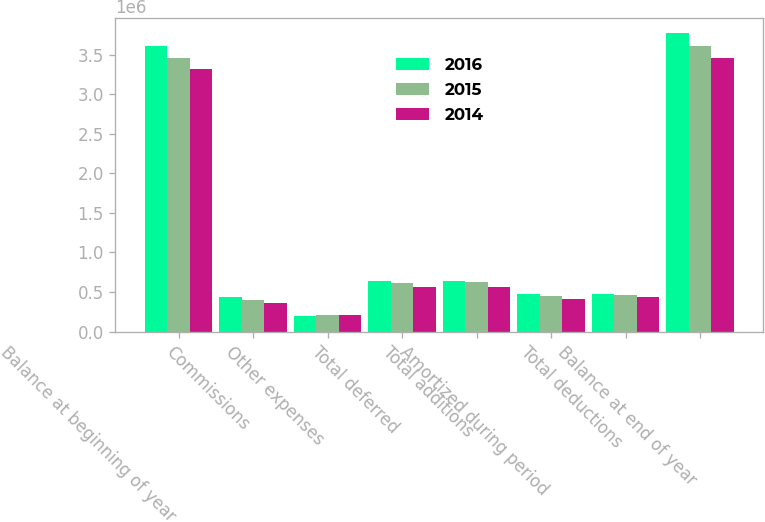<chart> <loc_0><loc_0><loc_500><loc_500><stacked_bar_chart><ecel><fcel>Balance at beginning of year<fcel>Commissions<fcel>Other expenses<fcel>Total deferred<fcel>Total additions<fcel>Amortized during period<fcel>Total deductions<fcel>Balance at end of year<nl><fcel>2016<fcel>3.61714e+06<fcel>436252<fcel>199066<fcel>635318<fcel>637498<fcel>469063<fcel>471475<fcel>3.78316e+06<nl><fcel>2015<fcel>3.4574e+06<fcel>401166<fcel>211015<fcel>612181<fcel>620863<fcel>445625<fcel>461125<fcel>3.61714e+06<nl><fcel>2014<fcel>3.32543e+06<fcel>358969<fcel>203276<fcel>562245<fcel>562245<fcel>415914<fcel>430281<fcel>3.4574e+06<nl></chart> 